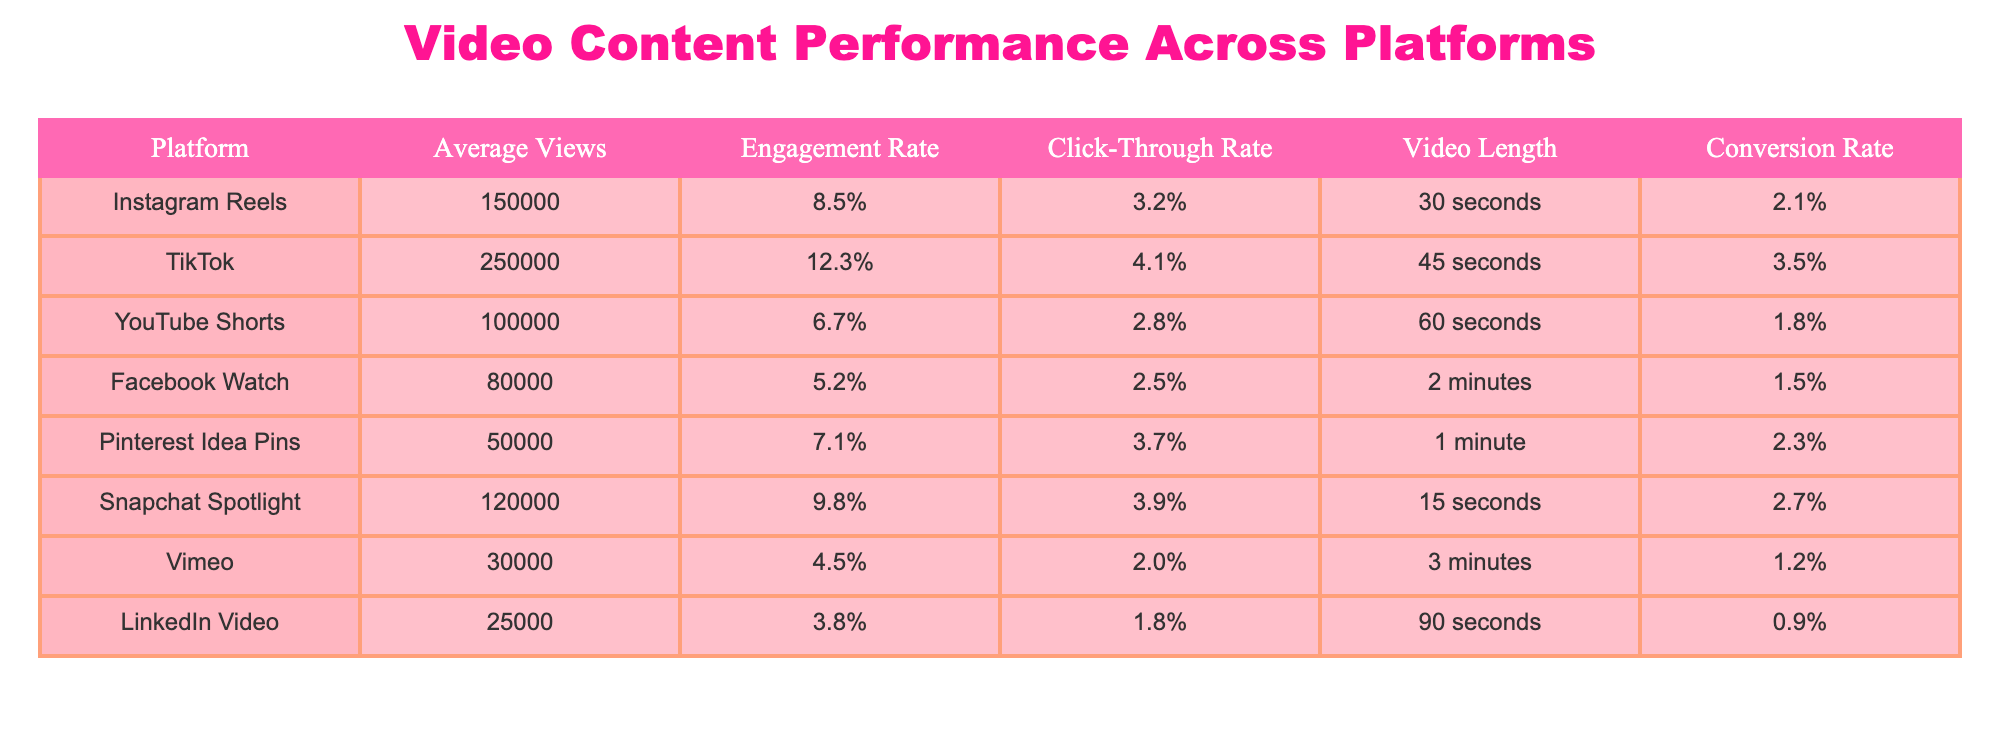What platform has the highest average views? Looking at the "Average Views" column, TikTok has the highest value at 250,000 views.
Answer: TikTok What is the engagement rate for YouTube Shorts? From the "Engagement Rate" column, YouTube Shorts has an engagement rate of 6.7%.
Answer: 6.7% Which platform has the lowest conversion rate? I will examine the "Conversion Rate" column. Vimeo has the lowest value at 1.2%.
Answer: Vimeo What is the average video length for Instagram Reels and Snapchat Spotlight combined? The video lengths are 30 seconds for Instagram Reels and 15 seconds for Snapchat Spotlight. Adding these gives a total of 45 seconds. Dividing by 2 to find the average results in 22.5 seconds.
Answer: 22.5 seconds Do TikTok videos have a higher click-through rate than Facebook Watch videos? Comparing the "Click-Through Rate" values, TikTok has 4.1% and Facebook Watch has 2.5%. Since 4.1% is greater than 2.5%, the statement is true.
Answer: Yes Which platform has an engagement rate of over 10%? Looking at the "Engagement Rate" column, only TikTok has an engagement rate higher than 10% at 12.3%.
Answer: TikTok What is the total average views across all platforms? I will sum the average views for each platform: 150,000 + 250,000 + 100,000 + 80,000 + 50,000 + 120,000 + 30,000 + 25,000 = 805,000 views.
Answer: 805,000 Does Snapchat Spotlight have a longer video length than Pinterest Idea Pins? Snapchat Spotlight has a video length of 15 seconds, and Pinterest Idea Pins have 1 minute (60 seconds). Since 15 seconds is less than 60 seconds, the answer is false.
Answer: No What is the difference in average views between TikTok and Instagram Reels? The average views for TikTok are 250,000 and for Instagram Reels are 150,000. The difference is 250,000 - 150,000 = 100,000 views.
Answer: 100,000 